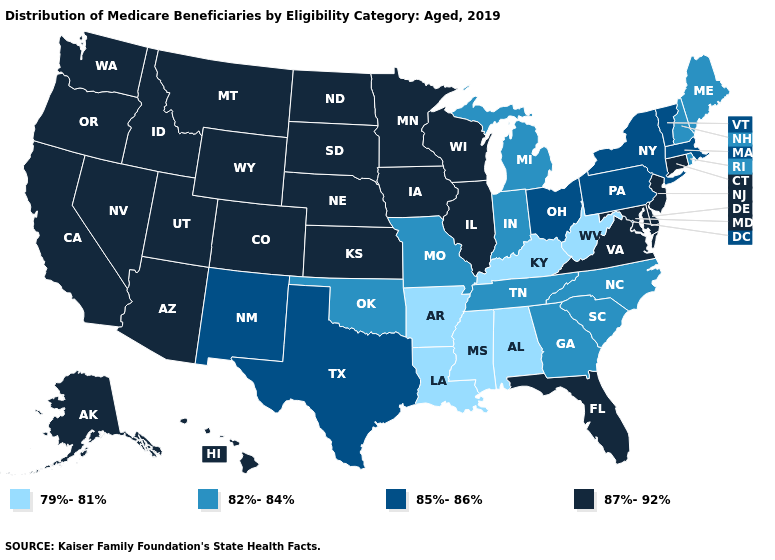What is the value of Michigan?
Keep it brief. 82%-84%. What is the highest value in the USA?
Be succinct. 87%-92%. Does the first symbol in the legend represent the smallest category?
Give a very brief answer. Yes. Name the states that have a value in the range 79%-81%?
Write a very short answer. Alabama, Arkansas, Kentucky, Louisiana, Mississippi, West Virginia. Does Illinois have the highest value in the USA?
Be succinct. Yes. What is the lowest value in states that border Delaware?
Quick response, please. 85%-86%. What is the lowest value in states that border Massachusetts?
Quick response, please. 82%-84%. What is the highest value in the USA?
Be succinct. 87%-92%. Does West Virginia have the lowest value in the USA?
Give a very brief answer. Yes. What is the value of Washington?
Write a very short answer. 87%-92%. What is the value of California?
Be succinct. 87%-92%. Name the states that have a value in the range 82%-84%?
Concise answer only. Georgia, Indiana, Maine, Michigan, Missouri, New Hampshire, North Carolina, Oklahoma, Rhode Island, South Carolina, Tennessee. How many symbols are there in the legend?
Be succinct. 4. Among the states that border Michigan , which have the lowest value?
Answer briefly. Indiana. What is the highest value in the West ?
Short answer required. 87%-92%. 